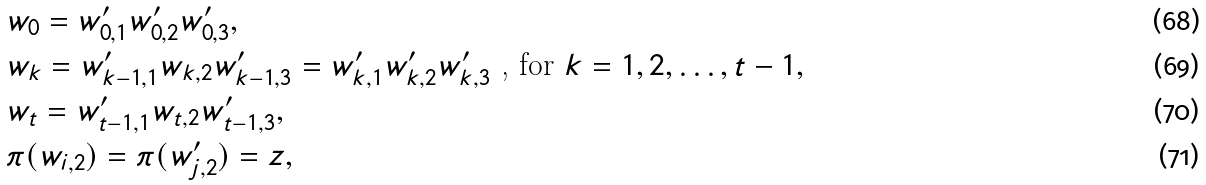<formula> <loc_0><loc_0><loc_500><loc_500>& w _ { 0 } = w _ { 0 , 1 } ^ { \prime } w _ { 0 , 2 } ^ { \prime } w _ { 0 , 3 } ^ { \prime } , \\ & w _ { k } = w _ { k - 1 , 1 } ^ { \prime } w _ { k , 2 } w _ { k - 1 , 3 } ^ { \prime } = w _ { k , 1 } ^ { \prime } w _ { k , 2 } ^ { \prime } w _ { k , 3 } ^ { \prime } \text { , for } k = 1 , 2 , \dots , t - 1 , \\ & w _ { t } = w _ { t - 1 , 1 } ^ { \prime } w _ { t , 2 } w _ { t - 1 , 3 } ^ { \prime } , \\ & \pi ( w _ { i , 2 } ) = \pi ( w _ { j , 2 } ^ { \prime } ) = z ,</formula> 